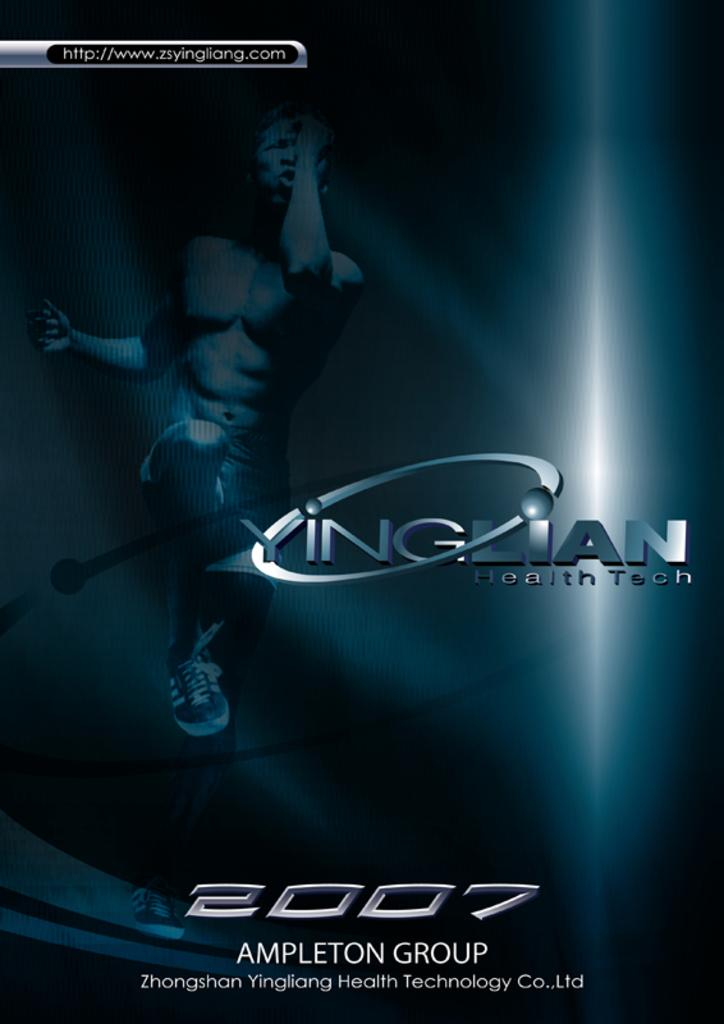<image>
Create a compact narrative representing the image presented. a page on 'http://www.zsyingliang.com' that says ampleton group at the bottom 